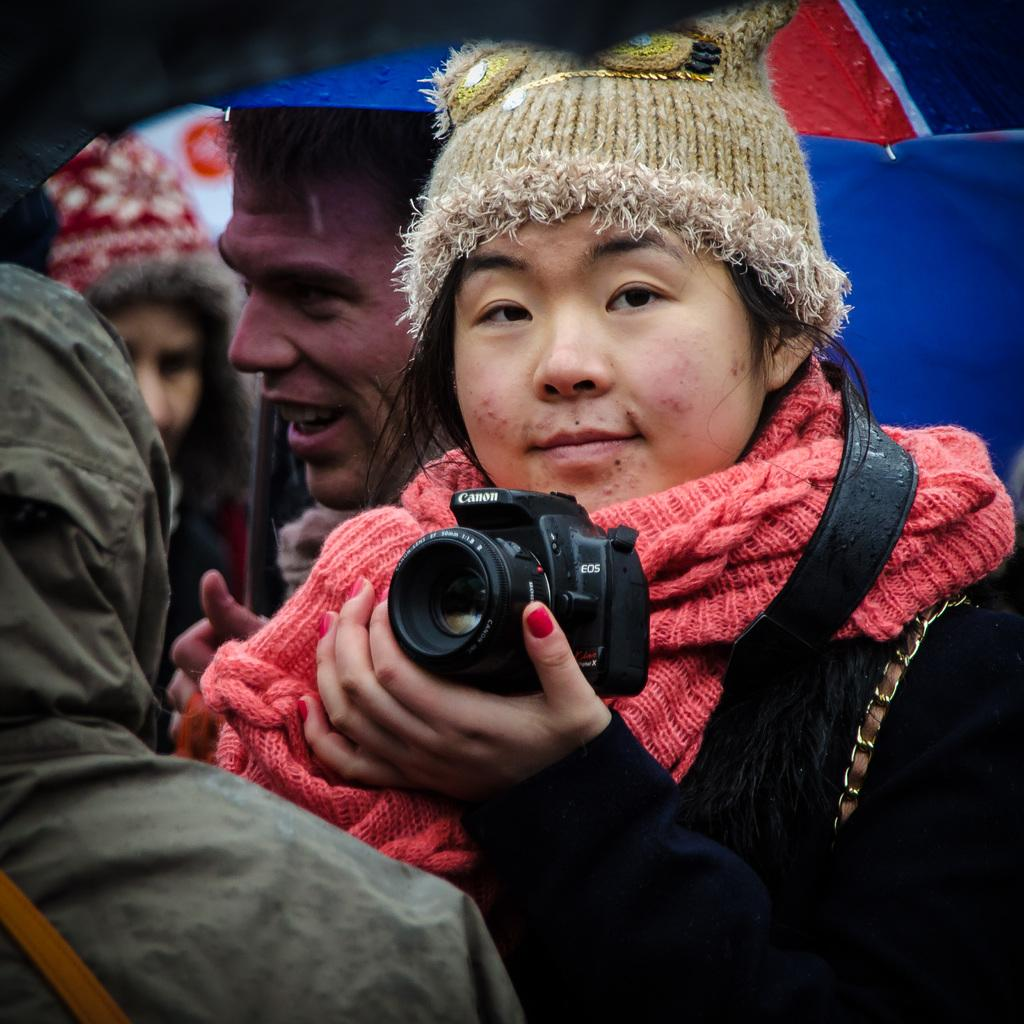Who is the main subject in the image? There is a lady in the image. What is the lady holding in her hand? The lady is holding a camera in one of her hands. Can you describe the background of the image? There are people in the background of the image. What type of airplane can be seen flying in the image? There is no airplane present in the image. How do the giants interact with the lady in the image? There are no giants present in the image. 